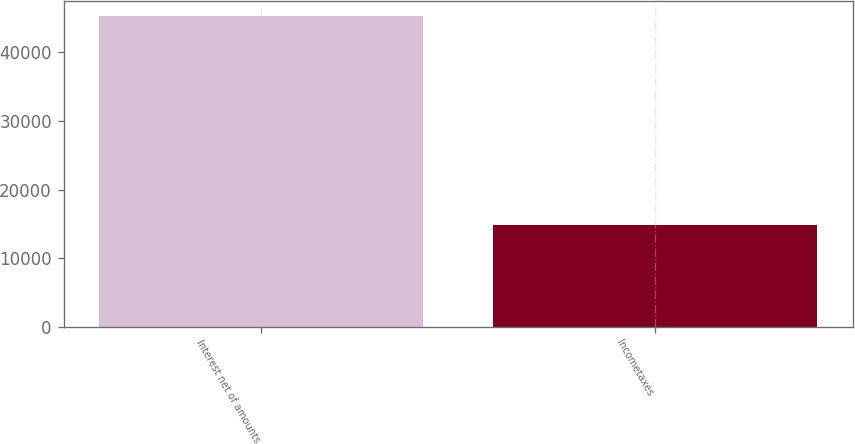Convert chart to OTSL. <chart><loc_0><loc_0><loc_500><loc_500><bar_chart><fcel>Interest net of amounts<fcel>Incometaxes<nl><fcel>45246<fcel>14853<nl></chart> 